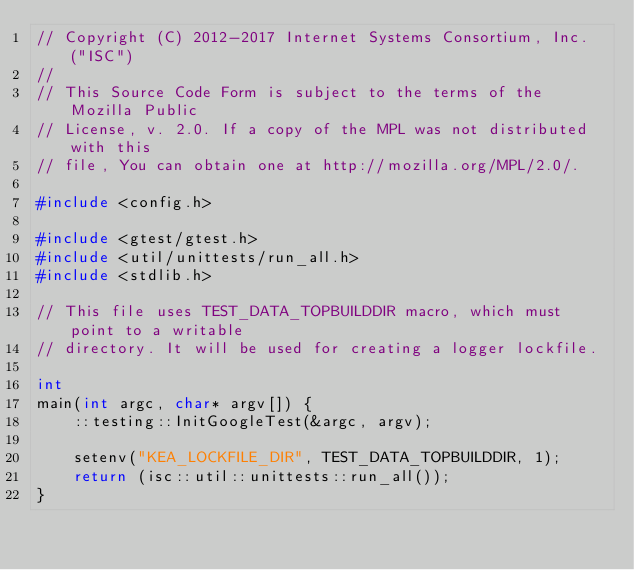Convert code to text. <code><loc_0><loc_0><loc_500><loc_500><_C++_>// Copyright (C) 2012-2017 Internet Systems Consortium, Inc. ("ISC")
//
// This Source Code Form is subject to the terms of the Mozilla Public
// License, v. 2.0. If a copy of the MPL was not distributed with this
// file, You can obtain one at http://mozilla.org/MPL/2.0/.

#include <config.h>

#include <gtest/gtest.h>
#include <util/unittests/run_all.h>
#include <stdlib.h>

// This file uses TEST_DATA_TOPBUILDDIR macro, which must point to a writable
// directory. It will be used for creating a logger lockfile.

int
main(int argc, char* argv[]) {
    ::testing::InitGoogleTest(&argc, argv);

    setenv("KEA_LOCKFILE_DIR", TEST_DATA_TOPBUILDDIR, 1);
    return (isc::util::unittests::run_all());
}
</code> 